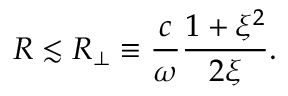Convert formula to latex. <formula><loc_0><loc_0><loc_500><loc_500>R \lesssim R _ { \bot } \equiv \frac { c } { \omega } \frac { 1 + \xi ^ { 2 } } { 2 \xi } .</formula> 